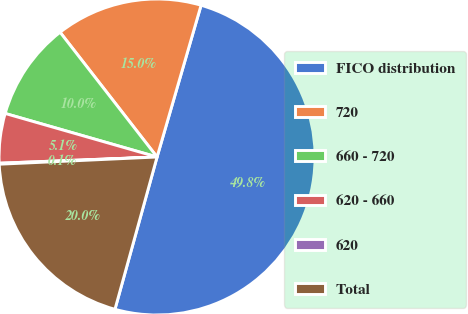Convert chart. <chart><loc_0><loc_0><loc_500><loc_500><pie_chart><fcel>FICO distribution<fcel>720<fcel>660 - 720<fcel>620 - 660<fcel>620<fcel>Total<nl><fcel>49.8%<fcel>15.01%<fcel>10.04%<fcel>5.07%<fcel>0.1%<fcel>19.98%<nl></chart> 